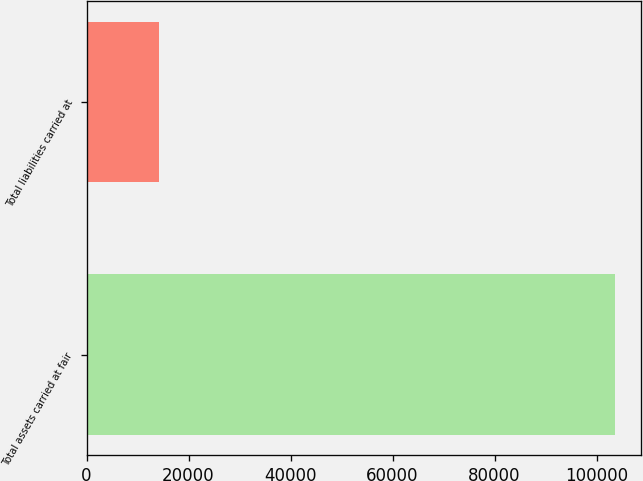Convert chart to OTSL. <chart><loc_0><loc_0><loc_500><loc_500><bar_chart><fcel>Total assets carried at fair<fcel>Total liabilities carried at<nl><fcel>103570<fcel>14162<nl></chart> 